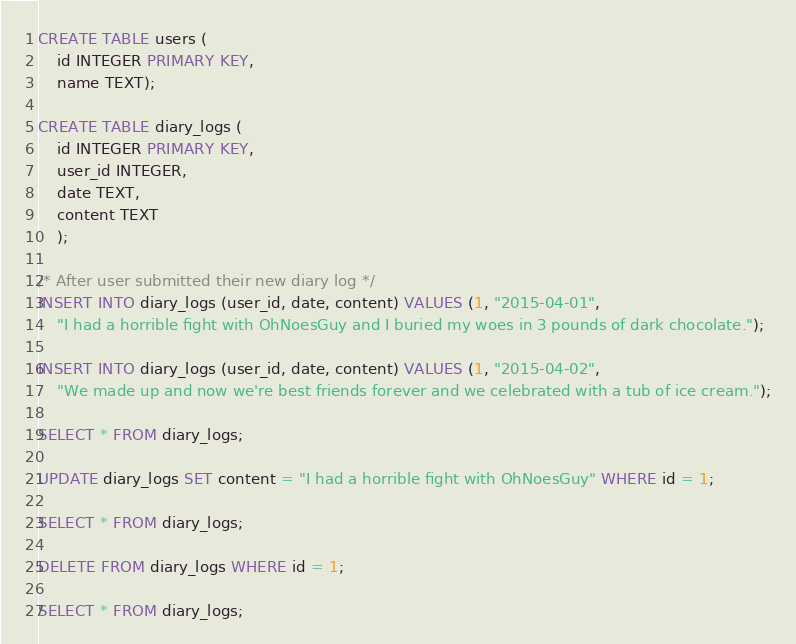Convert code to text. <code><loc_0><loc_0><loc_500><loc_500><_SQL_>CREATE TABLE users (
    id INTEGER PRIMARY KEY,
    name TEXT);
    
CREATE TABLE diary_logs (
    id INTEGER PRIMARY KEY,
    user_id INTEGER,
    date TEXT,
    content TEXT
    );
    
/* After user submitted their new diary log */
INSERT INTO diary_logs (user_id, date, content) VALUES (1, "2015-04-01",
    "I had a horrible fight with OhNoesGuy and I buried my woes in 3 pounds of dark chocolate.");
    
INSERT INTO diary_logs (user_id, date, content) VALUES (1, "2015-04-02",
    "We made up and now we're best friends forever and we celebrated with a tub of ice cream.");

SELECT * FROM diary_logs;

UPDATE diary_logs SET content = "I had a horrible fight with OhNoesGuy" WHERE id = 1;

SELECT * FROM diary_logs;

DELETE FROM diary_logs WHERE id = 1;

SELECT * FROM diary_logs;</code> 